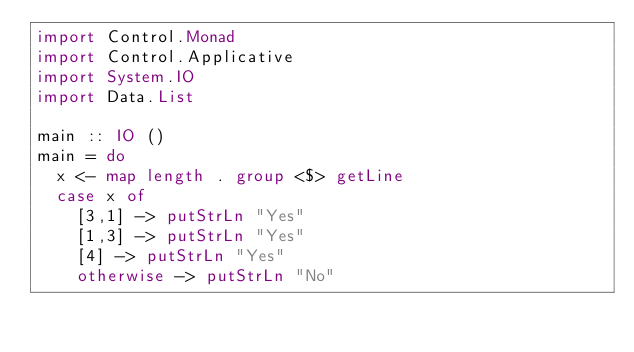Convert code to text. <code><loc_0><loc_0><loc_500><loc_500><_Haskell_>import Control.Monad
import Control.Applicative
import System.IO
import Data.List

main :: IO ()
main = do
  x <- map length . group <$> getLine
  case x of
    [3,1] -> putStrLn "Yes"
    [1,3] -> putStrLn "Yes"
    [4] -> putStrLn "Yes"
    otherwise -> putStrLn "No"</code> 